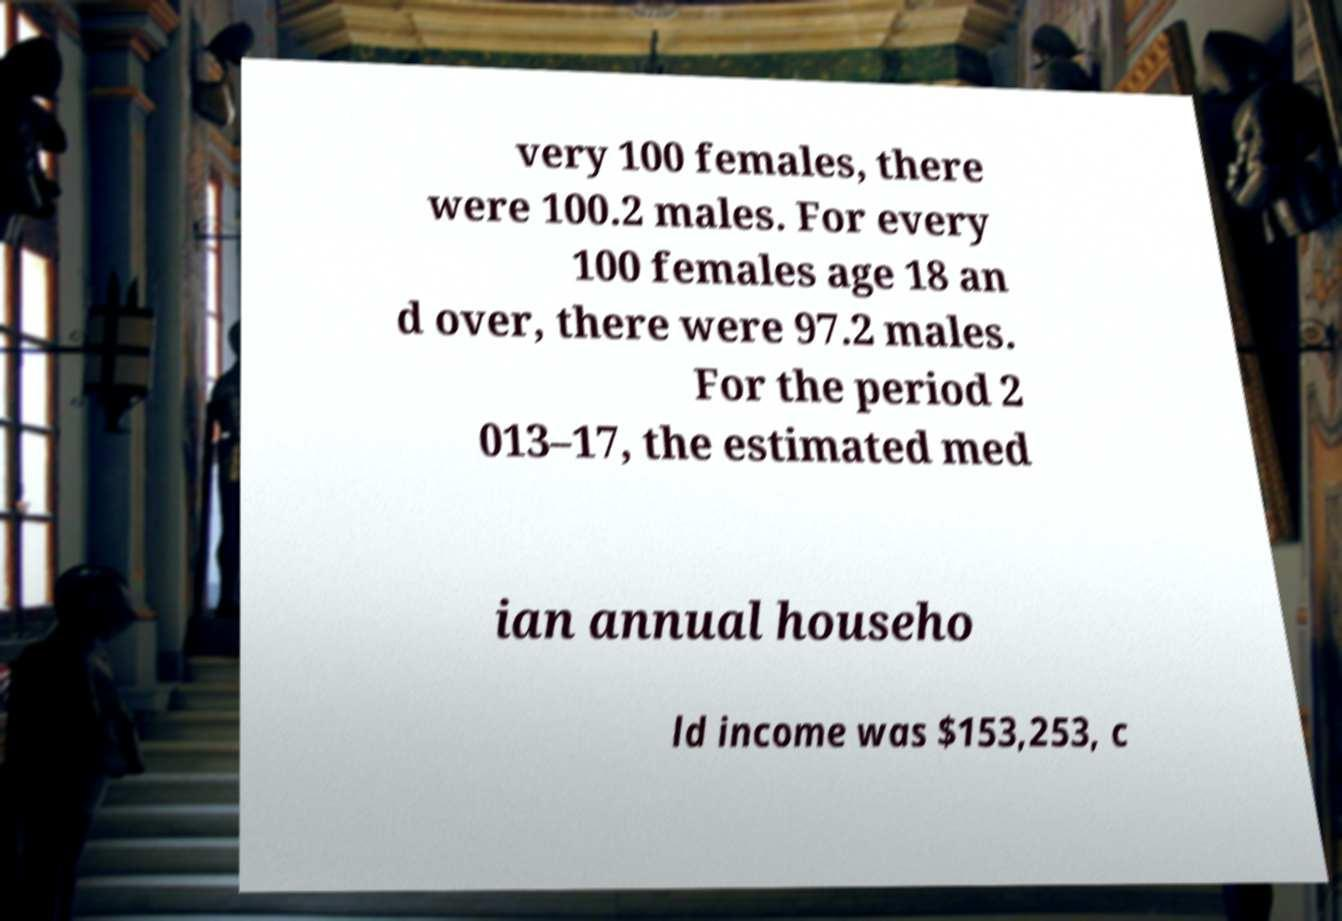Could you assist in decoding the text presented in this image and type it out clearly? very 100 females, there were 100.2 males. For every 100 females age 18 an d over, there were 97.2 males. For the period 2 013–17, the estimated med ian annual househo ld income was $153,253, c 